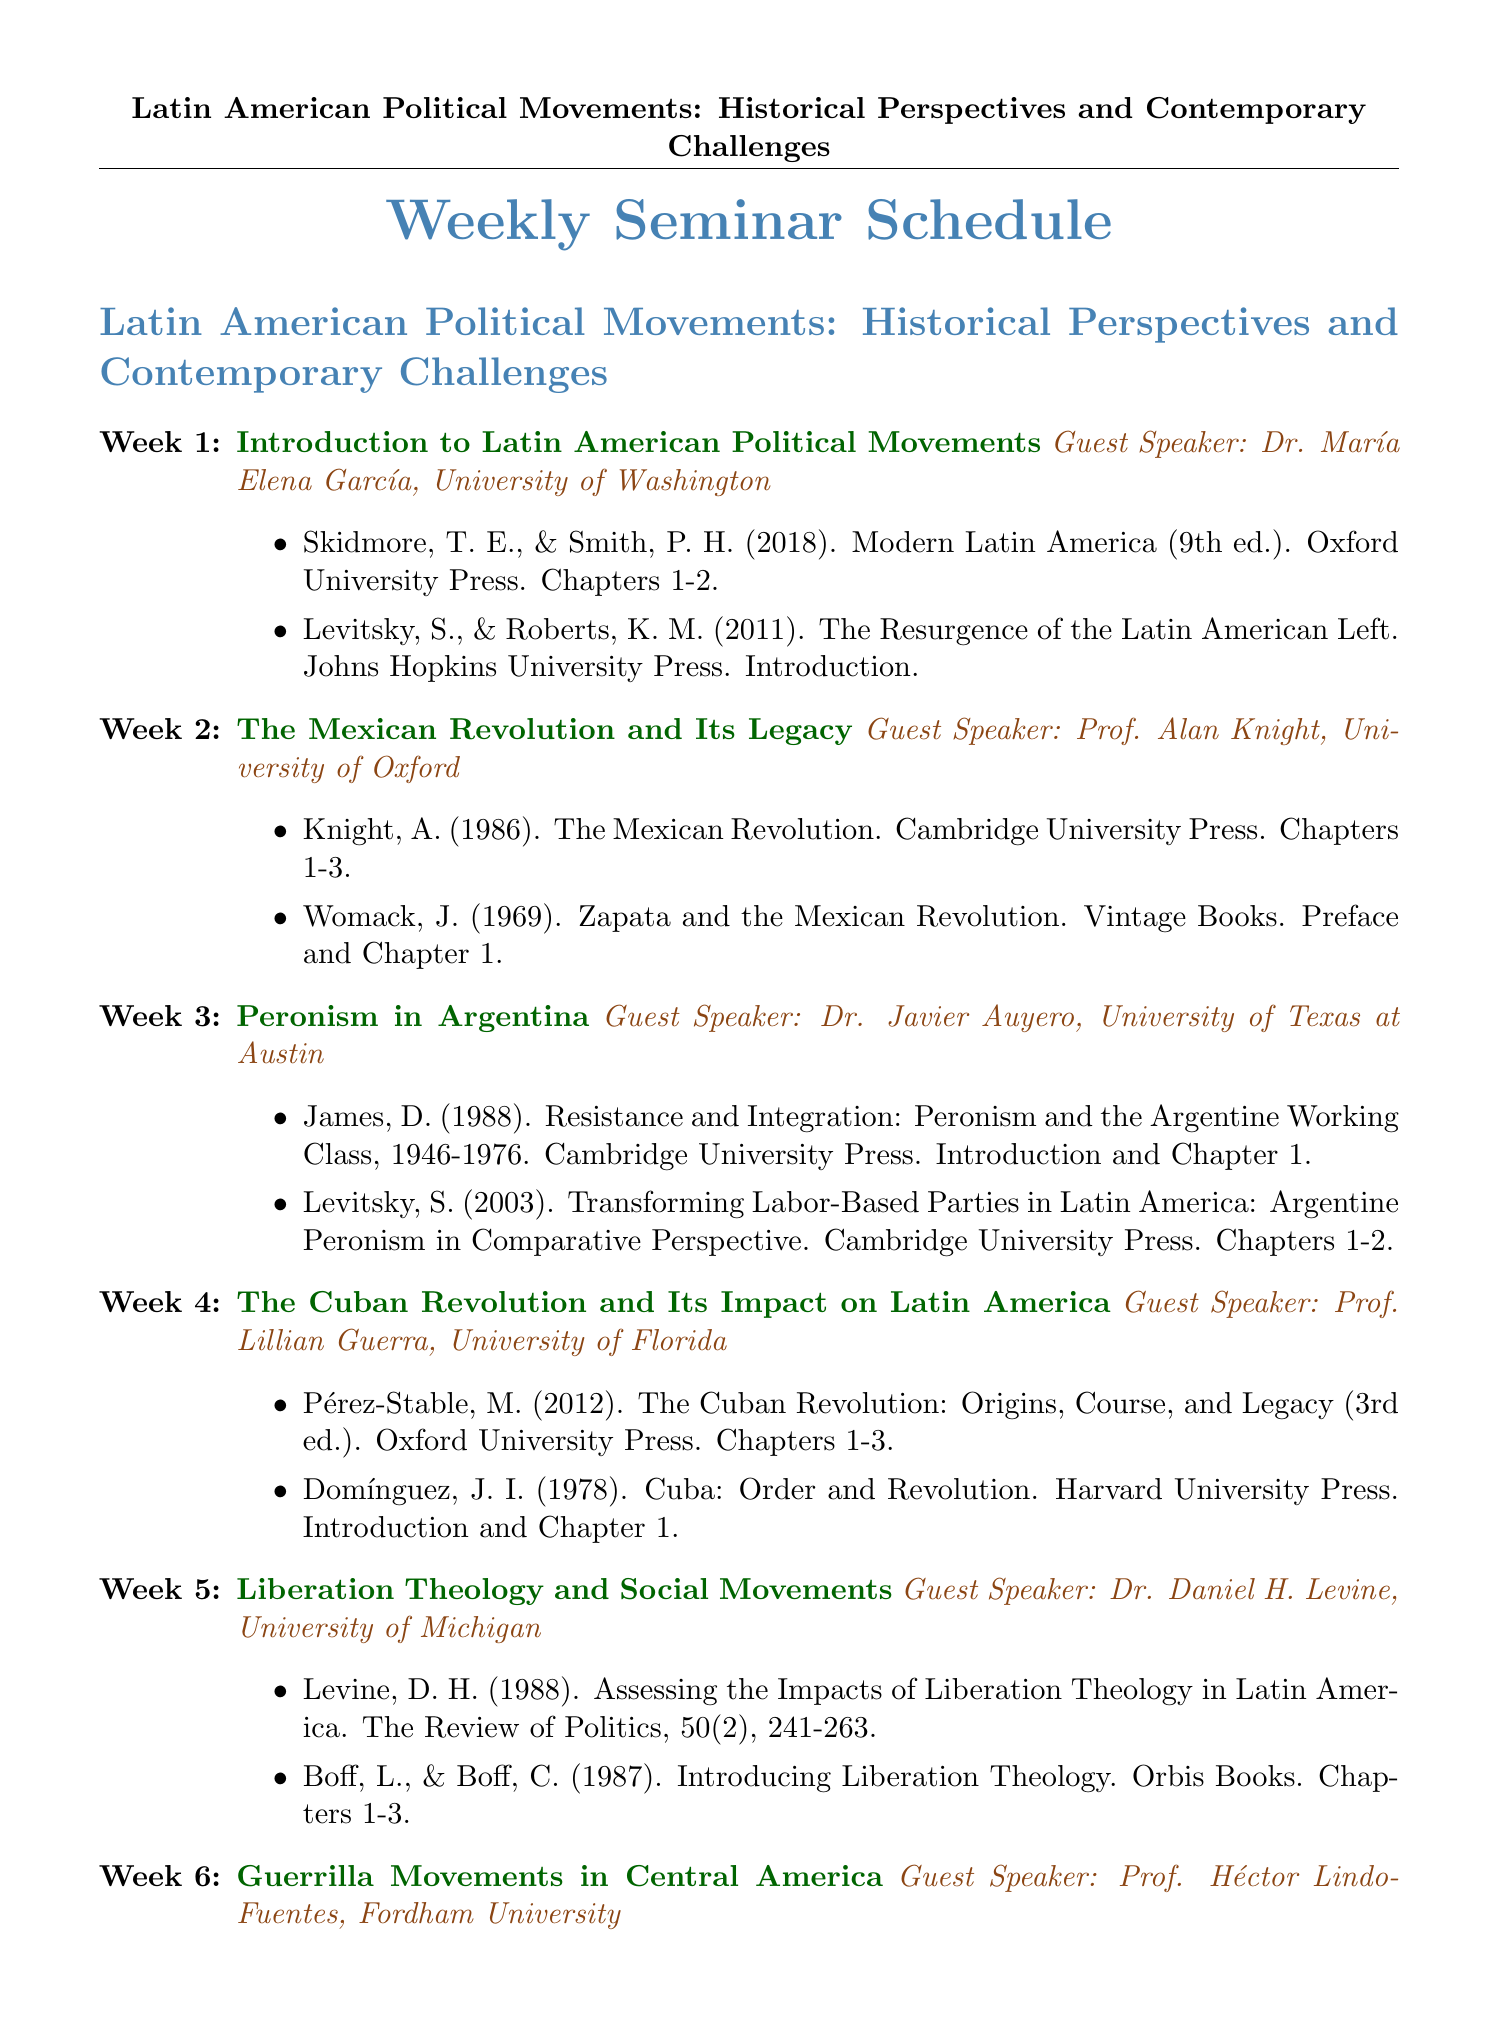What is the title of the seminar? The title is found at the beginning of the document and is "Latin American Political Movements: Historical Perspectives and Contemporary Challenges."
Answer: Latin American Political Movements: Historical Perspectives and Contemporary Challenges Who is the guest speaker for Week 3? The guest speaker for Week 3 is listed under the topic "Peronism in Argentina."
Answer: Dr. Javier Auyero, University of Texas at Austin How many weeks are scheduled for the seminar? The number of weeks can be counted from the list provided in the document.
Answer: 12 What topic is covered in Week 5? The topic is mentioned alongside the week number and must be retrieved from the document.
Answer: Liberation Theology and Social Movements Which reading is required for Week 10? This information can be found in the required readings section for Week 10.
Answer: Levitsky, S., & Roberts, K. M. (Eds.). (2011). The Resurgence of the Latin American Left. Johns Hopkins University Press. Chapters 1-2 What is the theme of the final seminar week? The theme can be found in the week topic listed at the end of the schedule.
Answer: Contemporary Challenges and Future Prospects for Latin American Political Movements 